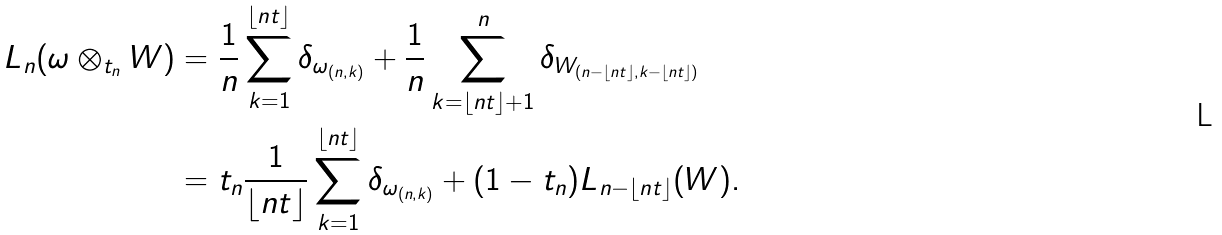Convert formula to latex. <formula><loc_0><loc_0><loc_500><loc_500>L _ { n } ( \omega \otimes _ { t _ { n } } W ) & = \frac { 1 } { n } \sum _ { k = 1 } ^ { \lfloor n t \rfloor } \delta _ { \omega _ { ( n , k ) } } + \frac { 1 } { n } \sum _ { k = \lfloor n t \rfloor + 1 } ^ { n } \delta _ { W _ { ( n - \lfloor n t \rfloor , k - \lfloor n t \rfloor ) } } \\ & = t _ { n } \frac { 1 } { \lfloor n t \rfloor } \sum _ { k = 1 } ^ { \lfloor n t \rfloor } \delta _ { \omega _ { ( n , k ) } } + ( 1 - t _ { n } ) L _ { n - \lfloor n t \rfloor } ( W ) .</formula> 